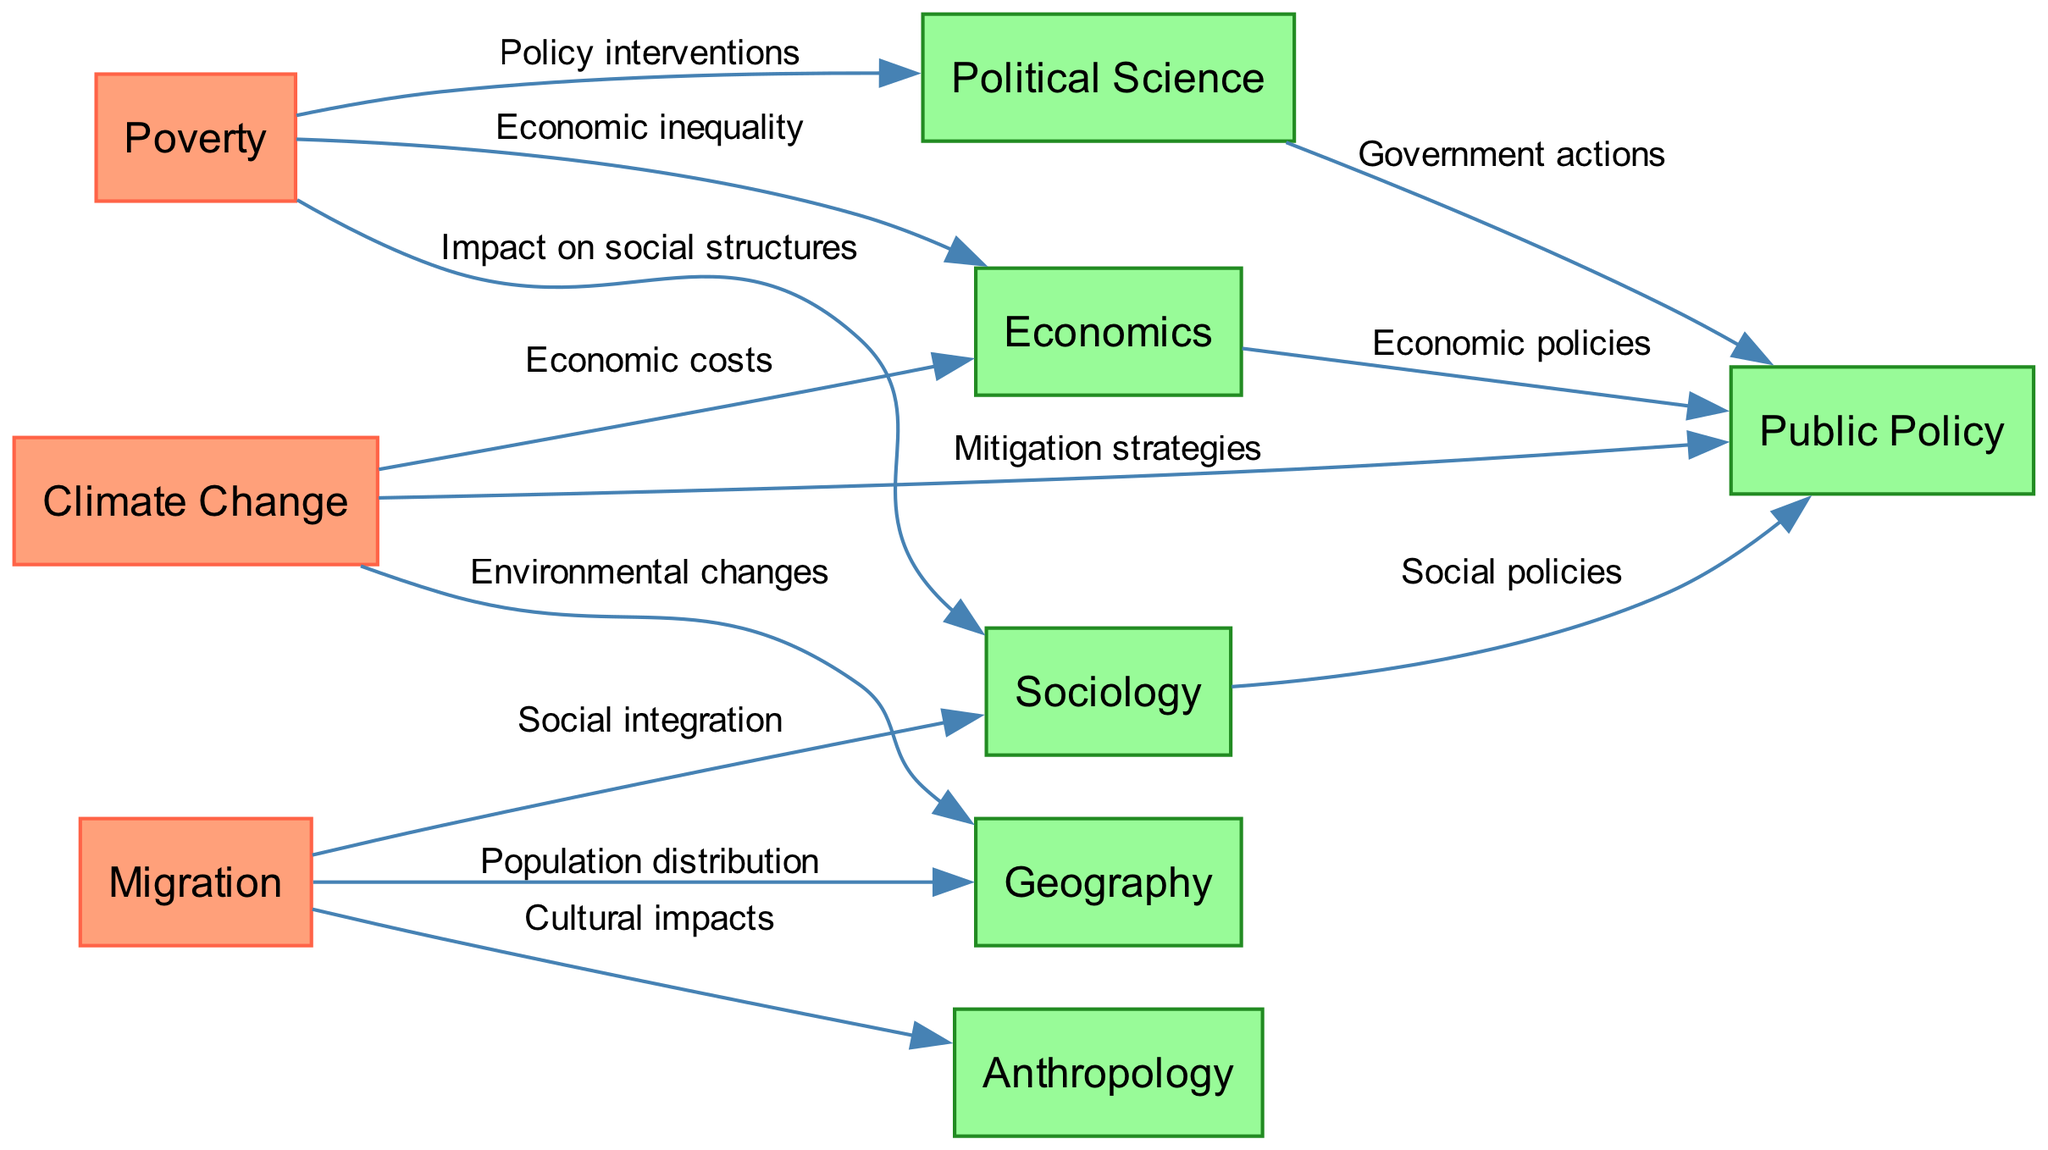What are the three primary global social issues represented in the diagram? The diagram contains three primary nodes representing global social issues: Poverty, Migration, and Climate Change. These are the central themes of the interconnected web.
Answer: Poverty, Migration, Climate Change How many academic disciplines are included in the diagram? The diagram includes five academic disciplines: Sociology, Economics, Political Science, Anthropology, and Geography. By counting the unique node labels in the discipline category, we find there are five disciplines.
Answer: 5 Which academic discipline is associated with the cultural impacts of migration? The diagram shows that Migration has an edge connecting to Anthropology, labeled as Cultural impacts. This indicates Anthropology is the discipline relating to cultural aspects within migration studies.
Answer: Anthropology What is one way poverty impacts political science? The relationship between Poverty and Political Science is labeled "Policy interventions." This shows that the discipline of Political Science examines policy interventions in response to issues of poverty.
Answer: Policy interventions What connection links climate change to public policy in the diagram? The diagram highlights a link from Climate Change to Public Policy, indicated with the label "Mitigation strategies." This signifies that discussions on public policy encompass strategies for mitigating the effects of climate change.
Answer: Mitigation strategies Which discipline is most related to the economic inequality stemming from poverty? The edge from Poverty to Economics is labeled "Economic inequality," suggesting that the discipline of Economics is primarily focused on the study of economic disparities associated with poverty.
Answer: Economics How many edges connect sociology to other concepts in the diagram? The Sociology node has edges connecting it to Public Policy and impacts from both Poverty and Migration, totaling three connections. This can be determined by counting the edges from the Sociology node to other nodes.
Answer: 3 What relationship does migration have with geography according to the diagram? Migration is linked to Geography with an edge labeled "Population distribution." This indicates Geography studies the impacts of migration on how populations are distributed across different areas.
Answer: Population distribution 